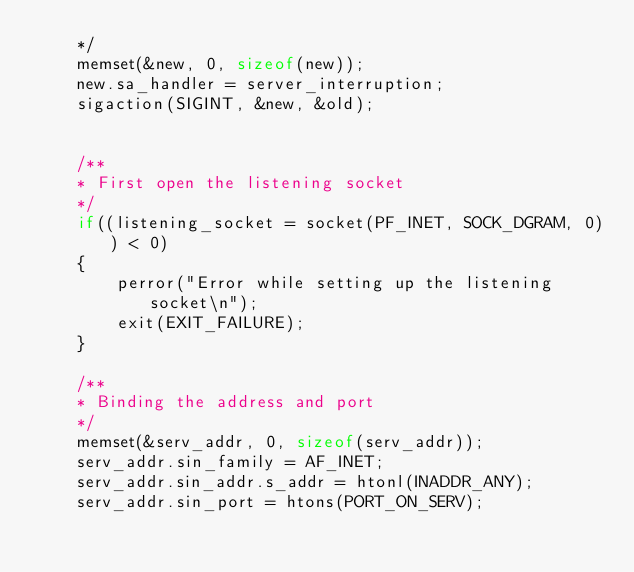Convert code to text. <code><loc_0><loc_0><loc_500><loc_500><_C_>	*/
	memset(&new, 0, sizeof(new));
	new.sa_handler = server_interruption;
	sigaction(SIGINT, &new, &old);


	/**
	* First open the listening socket
	*/
	if((listening_socket = socket(PF_INET, SOCK_DGRAM, 0)) < 0)
	{
		perror("Error while setting up the listening socket\n");
		exit(EXIT_FAILURE);
	}

	/**
	* Binding the address and port
	*/
	memset(&serv_addr, 0, sizeof(serv_addr));
	serv_addr.sin_family = AF_INET;
	serv_addr.sin_addr.s_addr = htonl(INADDR_ANY);
	serv_addr.sin_port = htons(PORT_ON_SERV);
</code> 